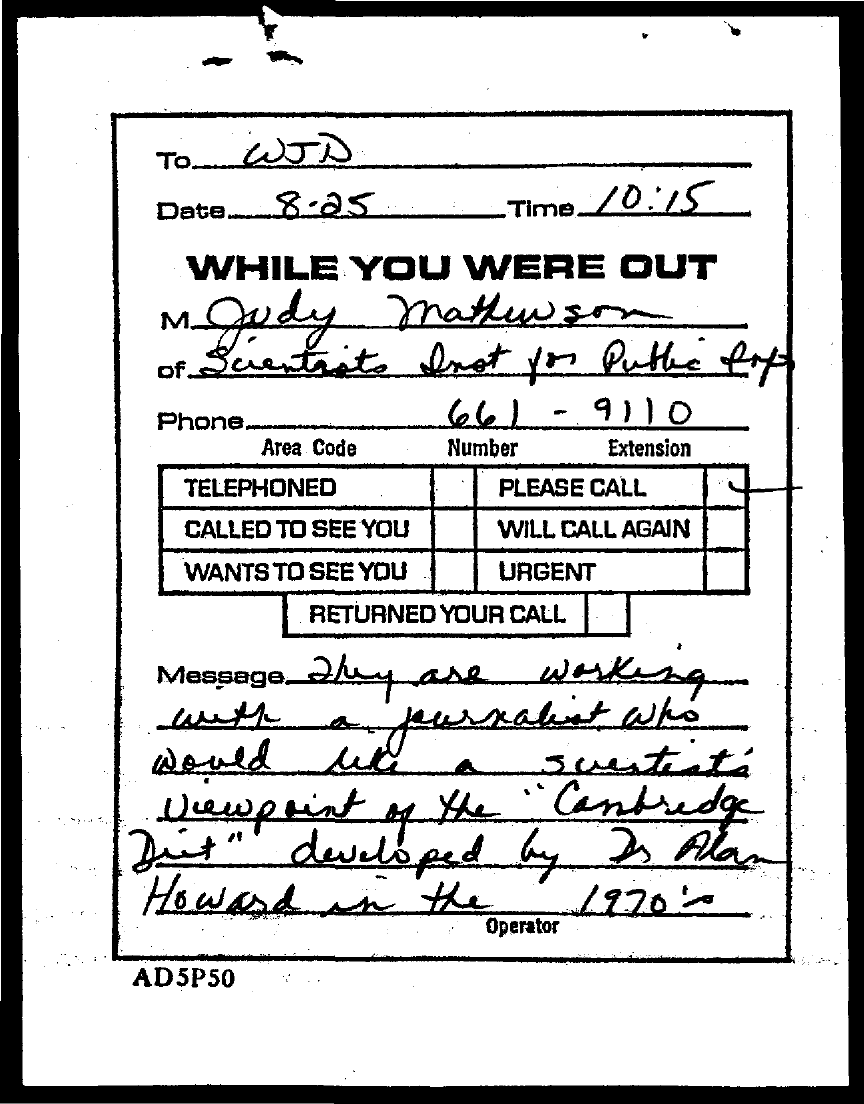Draw attention to some important aspects in this diagram. The time mentioned in this document is 10:15. The message is addressed to "To whom. The date mentioned in this document is 8.25.. The phone number of Judy Mathewson is 661-9110. 